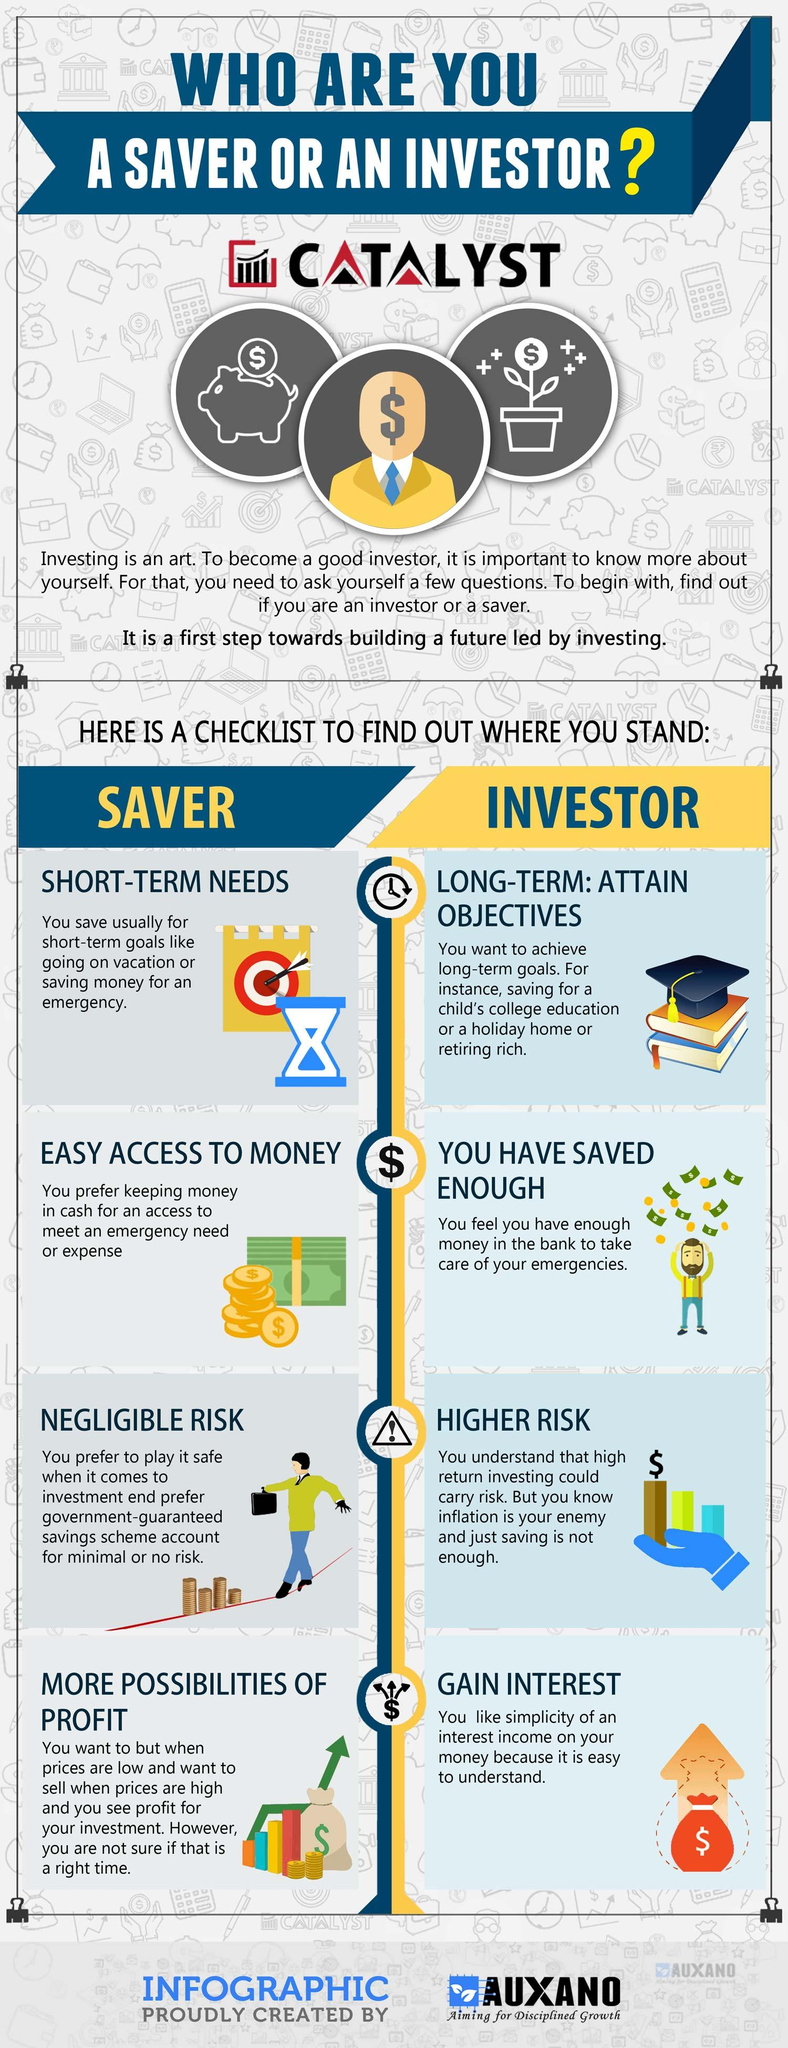Give some essential details in this illustration. The individual who is at a higher risk is the INVESTOR. 